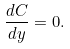<formula> <loc_0><loc_0><loc_500><loc_500>\frac { d C } { d y } = 0 .</formula> 